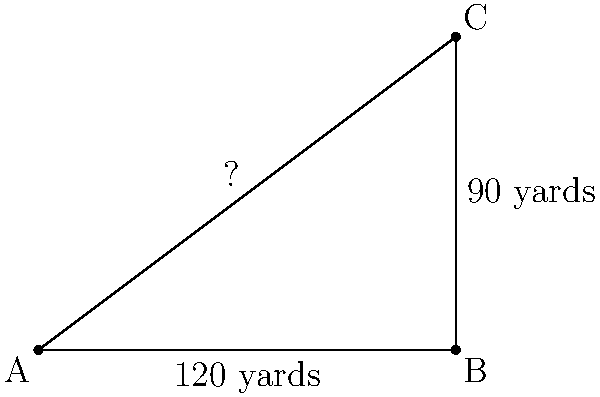On a golf course, you're standing at point A and need to reach the flag at point C. You can see that point C is directly north of point B, which is 120 yards east of your position. If the distance between B and C is 90 yards, how far are you from the flag in a straight line? To solve this problem, we can use the Pythagorean theorem. Let's approach this step-by-step:

1) We have a right-angled triangle ABC, where:
   - AB = 120 yards (east direction)
   - BC = 90 yards (north direction)
   - AC is the distance we need to find

2) The Pythagorean theorem states that in a right-angled triangle:
   $a^2 + b^2 = c^2$, where c is the hypotenuse (longest side)

3) In our case:
   $AB^2 + BC^2 = AC^2$

4) Let's substitute the known values:
   $120^2 + 90^2 = AC^2$

5) Calculate:
   $14400 + 8100 = AC^2$
   $22500 = AC^2$

6) To find AC, we need to take the square root of both sides:
   $\sqrt{22500} = AC$

7) Simplify:
   $AC = 150$ yards

Therefore, the straight-line distance from your position (A) to the flag (C) is 150 yards.
Answer: 150 yards 